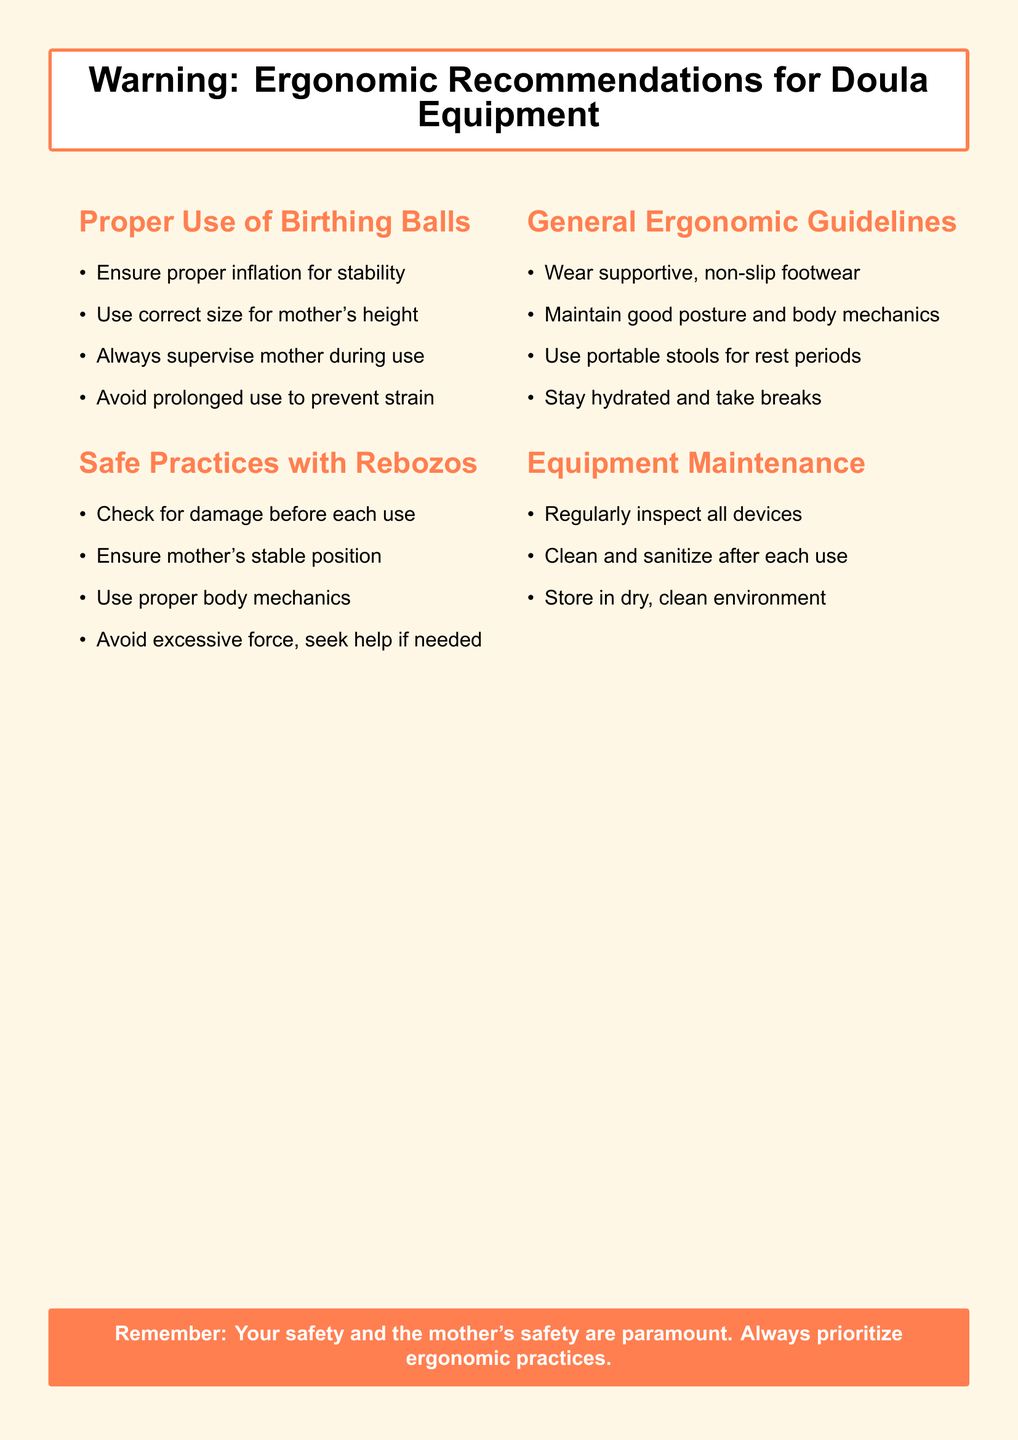What is the purpose of the document? The document provides ergonomic recommendations specifically for doulas using different types of equipment.
Answer: Ergonomic recommendations for doula equipment What should be ensured before using a birthing ball? The document states that proper inflation is necessary for stability when using a birthing ball.
Answer: Proper inflation for stability How should a doula check a rebozo before use? According to the document, a doula should check for damage before each use of a rebozo.
Answer: Check for damage What is one of the general ergonomic guidelines mentioned? The document mentions that doulas should wear supportive, non-slip footwear as a guideline.
Answer: Wear supportive, non-slip footwear How should equipment be stored after use? The document advises that equipment should be stored in a dry, clean environment.
Answer: Dry, clean environment What should be maintained to prevent injury while assisting a mother? The document emphasizes maintaining good posture and body mechanics to prevent injury.
Answer: Good posture and body mechanics What type of footwear is recommended for safety? The document recommends wearing supportive, non-slip footwear to ensure safety.
Answer: Supportive, non-slip footwear What is a recommended practice after using doula equipment? The document indicates that equipment should be cleaned and sanitized after each use.
Answer: Clean and sanitize How can a doula ensure the mother's stable position when using rebozos? By using proper body mechanics, a doula can help ensure the mother's stable position.
Answer: Proper body mechanics 